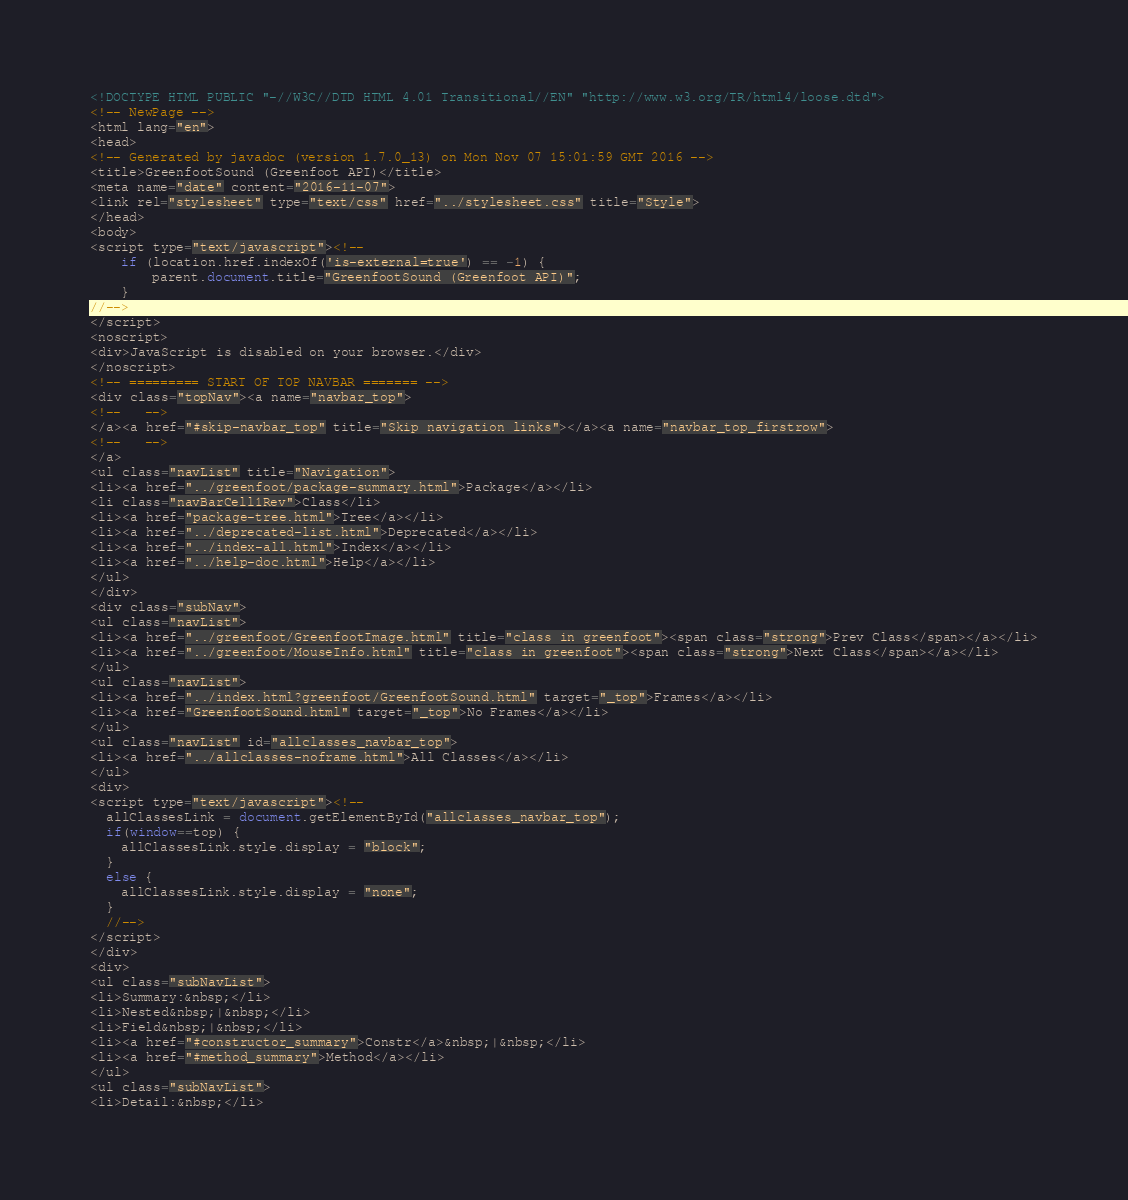Convert code to text. <code><loc_0><loc_0><loc_500><loc_500><_HTML_><!DOCTYPE HTML PUBLIC "-//W3C//DTD HTML 4.01 Transitional//EN" "http://www.w3.org/TR/html4/loose.dtd">
<!-- NewPage -->
<html lang="en">
<head>
<!-- Generated by javadoc (version 1.7.0_13) on Mon Nov 07 15:01:59 GMT 2016 -->
<title>GreenfootSound (Greenfoot API)</title>
<meta name="date" content="2016-11-07">
<link rel="stylesheet" type="text/css" href="../stylesheet.css" title="Style">
</head>
<body>
<script type="text/javascript"><!--
    if (location.href.indexOf('is-external=true') == -1) {
        parent.document.title="GreenfootSound (Greenfoot API)";
    }
//-->
</script>
<noscript>
<div>JavaScript is disabled on your browser.</div>
</noscript>
<!-- ========= START OF TOP NAVBAR ======= -->
<div class="topNav"><a name="navbar_top">
<!--   -->
</a><a href="#skip-navbar_top" title="Skip navigation links"></a><a name="navbar_top_firstrow">
<!--   -->
</a>
<ul class="navList" title="Navigation">
<li><a href="../greenfoot/package-summary.html">Package</a></li>
<li class="navBarCell1Rev">Class</li>
<li><a href="package-tree.html">Tree</a></li>
<li><a href="../deprecated-list.html">Deprecated</a></li>
<li><a href="../index-all.html">Index</a></li>
<li><a href="../help-doc.html">Help</a></li>
</ul>
</div>
<div class="subNav">
<ul class="navList">
<li><a href="../greenfoot/GreenfootImage.html" title="class in greenfoot"><span class="strong">Prev Class</span></a></li>
<li><a href="../greenfoot/MouseInfo.html" title="class in greenfoot"><span class="strong">Next Class</span></a></li>
</ul>
<ul class="navList">
<li><a href="../index.html?greenfoot/GreenfootSound.html" target="_top">Frames</a></li>
<li><a href="GreenfootSound.html" target="_top">No Frames</a></li>
</ul>
<ul class="navList" id="allclasses_navbar_top">
<li><a href="../allclasses-noframe.html">All Classes</a></li>
</ul>
<div>
<script type="text/javascript"><!--
  allClassesLink = document.getElementById("allclasses_navbar_top");
  if(window==top) {
    allClassesLink.style.display = "block";
  }
  else {
    allClassesLink.style.display = "none";
  }
  //-->
</script>
</div>
<div>
<ul class="subNavList">
<li>Summary:&nbsp;</li>
<li>Nested&nbsp;|&nbsp;</li>
<li>Field&nbsp;|&nbsp;</li>
<li><a href="#constructor_summary">Constr</a>&nbsp;|&nbsp;</li>
<li><a href="#method_summary">Method</a></li>
</ul>
<ul class="subNavList">
<li>Detail:&nbsp;</li></code> 